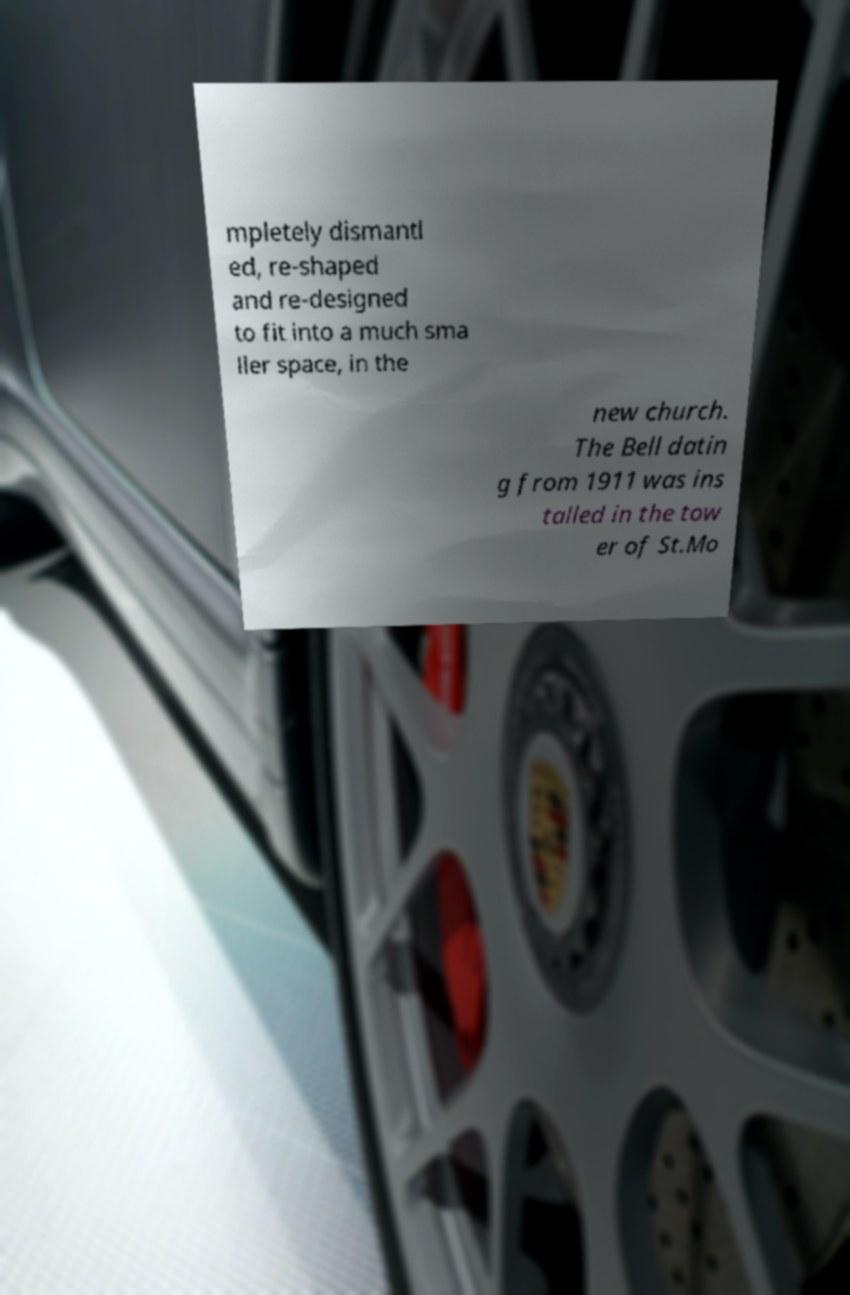Please identify and transcribe the text found in this image. mpletely dismantl ed, re-shaped and re-designed to fit into a much sma ller space, in the new church. The Bell datin g from 1911 was ins talled in the tow er of St.Mo 